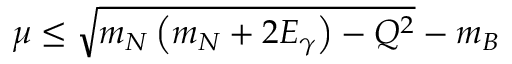<formula> <loc_0><loc_0><loc_500><loc_500>\mu \leq \sqrt { m _ { N } \left ( m _ { N } + 2 E _ { \gamma } \right ) - Q ^ { 2 } } - m _ { B }</formula> 